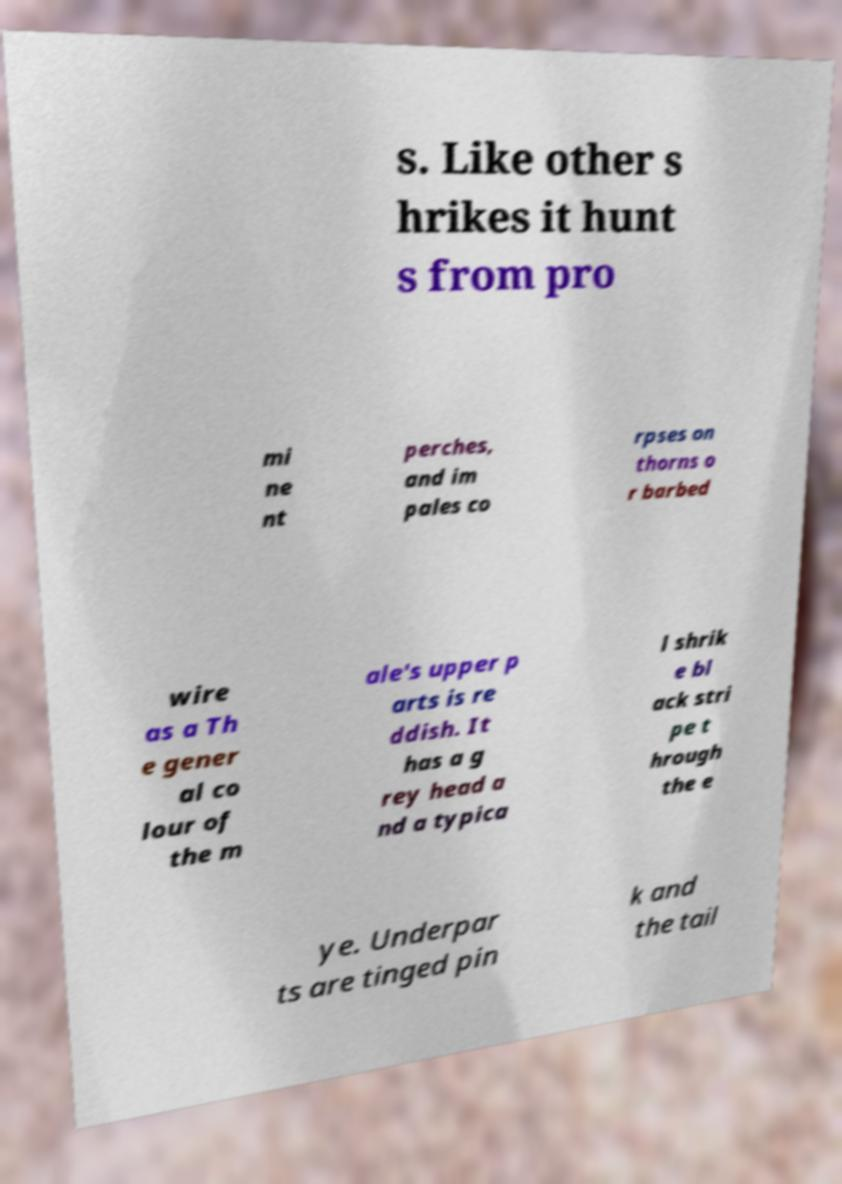Could you extract and type out the text from this image? s. Like other s hrikes it hunt s from pro mi ne nt perches, and im pales co rpses on thorns o r barbed wire as a Th e gener al co lour of the m ale's upper p arts is re ddish. It has a g rey head a nd a typica l shrik e bl ack stri pe t hrough the e ye. Underpar ts are tinged pin k and the tail 